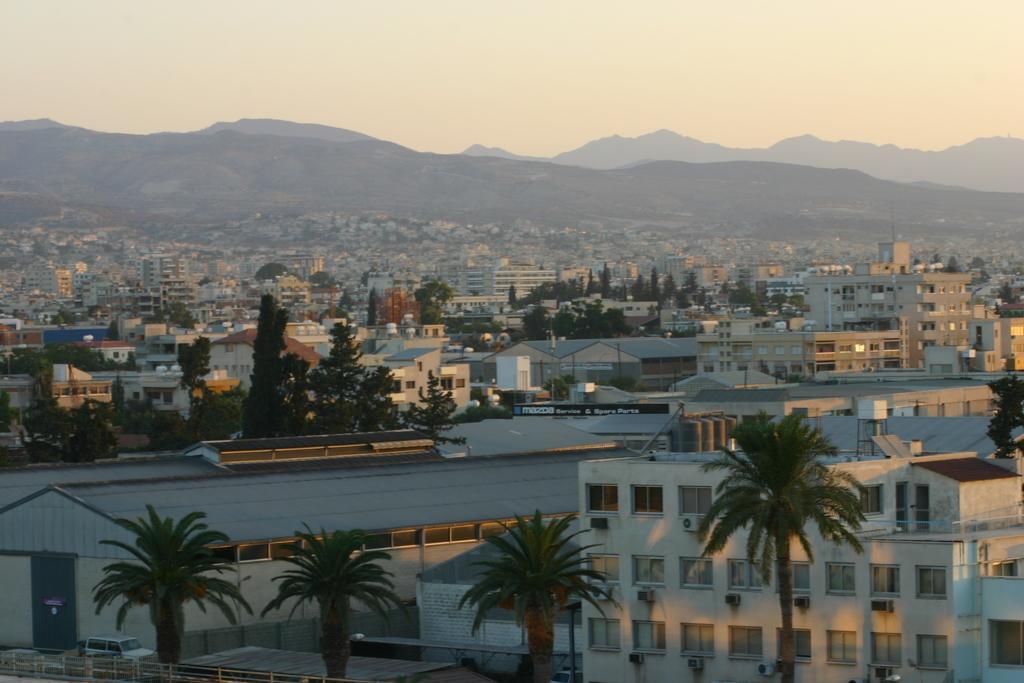In one or two sentences, can you explain what this image depicts? In this image we can see a few buildings, trees, mountains and fence, also we can see a vehicle and in the background, we can see the sky. 